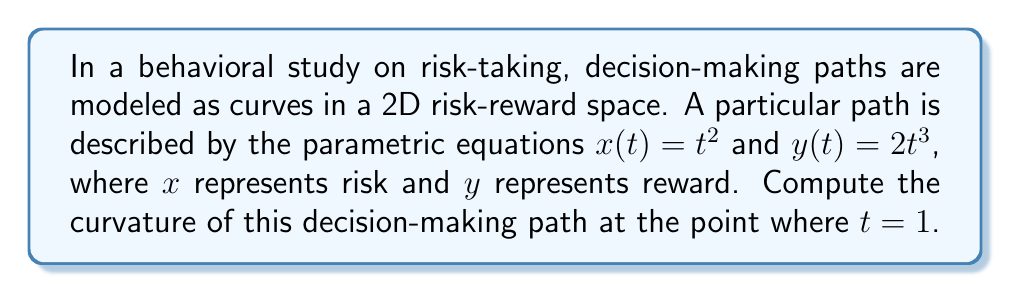Could you help me with this problem? To compute the curvature of the decision-making path, we'll follow these steps:

1) The curvature $\kappa$ of a parametric curve $(x(t), y(t))$ is given by:

   $$\kappa = \frac{|x'y'' - y'x''|}{(x'^2 + y'^2)^{3/2}}$$

2) Let's calculate the first and second derivatives:
   $x' = 2t$
   $y' = 6t^2$
   $x'' = 2$
   $y'' = 12t$

3) Now, let's substitute these into the curvature formula:

   $$\kappa = \frac{|2t \cdot 12t - 6t^2 \cdot 2|}{(4t^2 + 36t^4)^{3/2}}$$

4) Simplify:
   $$\kappa = \frac{|24t^2 - 12t^2|}{(4t^2 + 36t^4)^{3/2}} = \frac{12t^2}{(4t^2 + 36t^4)^{3/2}}$$

5) We need to evaluate this at $t = 1$:

   $$\kappa_{t=1} = \frac{12}{(4 + 36)^{3/2}} = \frac{12}{40^{3/2}}$$

6) Simplify:
   $$\kappa_{t=1} = \frac{12}{40^{3/2}} = \frac{3}{10\sqrt{10}}$$

This curvature value indicates how sharply the decision-making path is turning at the point where $t = 1$ in the risk-reward space.
Answer: $\frac{3}{10\sqrt{10}}$ 